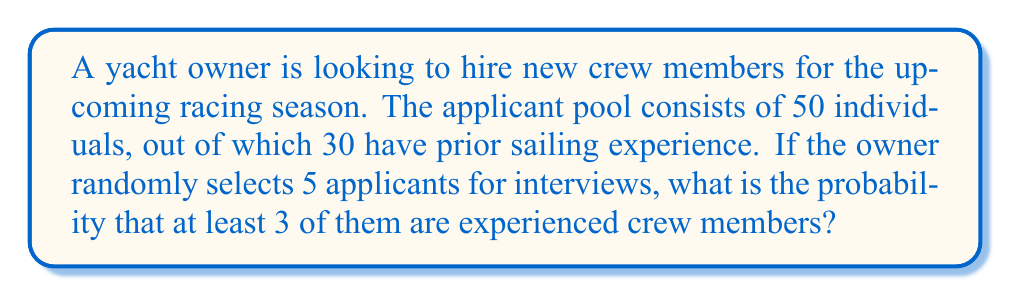Can you answer this question? Let's approach this step-by-step using the concept of complement probability and the hypergeometric distribution:

1) First, we need to calculate the probability of selecting 0, 1, or 2 experienced crew members, and then subtract this from 1 to get the probability of selecting at least 3.

2) We can use the hypergeometric distribution formula:

   $$P(X = k) = \frac{\binom{K}{k} \binom{N-K}{n-k}}{\binom{N}{n}}$$

   Where:
   $N$ = total number of applicants = 50
   $K$ = number of experienced crew members = 30
   $n$ = number of applicants selected = 5
   $k$ = number of experienced crew members in the selection (0, 1, or 2)

3) Let's calculate each probability:

   For $k = 0$:
   $$P(X = 0) = \frac{\binom{30}{0} \binom{20}{5}}{\binom{50}{5}} = \frac{1 \cdot 15504}{2118760} = 0.00732$$

   For $k = 1$:
   $$P(X = 1) = \frac{\binom{30}{1} \binom{20}{4}}{\binom{50}{5}} = \frac{30 \cdot 4845}{2118760} = 0.06853$$

   For $k = 2$:
   $$P(X = 2) = \frac{\binom{30}{2} \binom{20}{3}}{\binom{50}{5}} = \frac{435 \cdot 1140}{2118760} = 0.23452$$

4) The probability of selecting 0, 1, or 2 experienced crew members is the sum of these probabilities:

   $$P(X \leq 2) = 0.00732 + 0.06853 + 0.23452 = 0.31037$$

5) Therefore, the probability of selecting at least 3 experienced crew members is:

   $$P(X \geq 3) = 1 - P(X \leq 2) = 1 - 0.31037 = 0.68963$$
Answer: $0.68963$ or approximately $68.96\%$ 